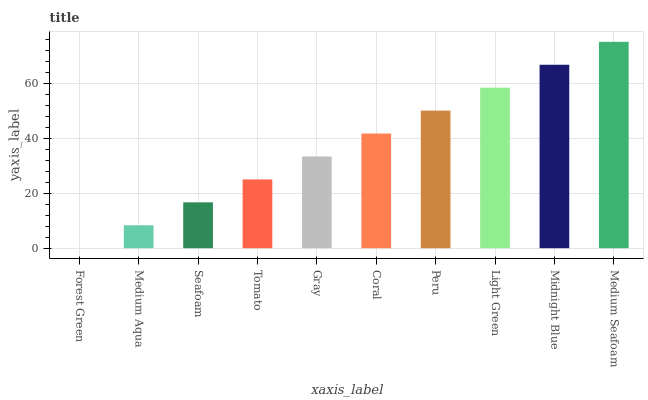Is Forest Green the minimum?
Answer yes or no. Yes. Is Medium Seafoam the maximum?
Answer yes or no. Yes. Is Medium Aqua the minimum?
Answer yes or no. No. Is Medium Aqua the maximum?
Answer yes or no. No. Is Medium Aqua greater than Forest Green?
Answer yes or no. Yes. Is Forest Green less than Medium Aqua?
Answer yes or no. Yes. Is Forest Green greater than Medium Aqua?
Answer yes or no. No. Is Medium Aqua less than Forest Green?
Answer yes or no. No. Is Coral the high median?
Answer yes or no. Yes. Is Gray the low median?
Answer yes or no. Yes. Is Seafoam the high median?
Answer yes or no. No. Is Light Green the low median?
Answer yes or no. No. 